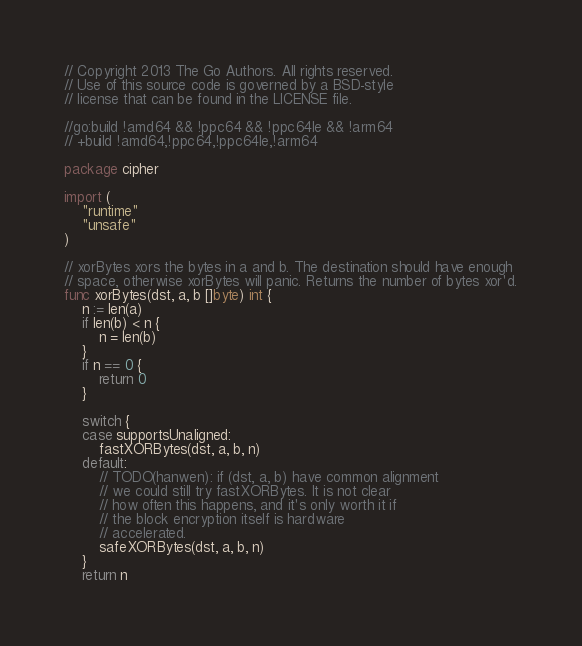Convert code to text. <code><loc_0><loc_0><loc_500><loc_500><_Go_>// Copyright 2013 The Go Authors. All rights reserved.
// Use of this source code is governed by a BSD-style
// license that can be found in the LICENSE file.

//go:build !amd64 && !ppc64 && !ppc64le && !arm64
// +build !amd64,!ppc64,!ppc64le,!arm64

package cipher

import (
	"runtime"
	"unsafe"
)

// xorBytes xors the bytes in a and b. The destination should have enough
// space, otherwise xorBytes will panic. Returns the number of bytes xor'd.
func xorBytes(dst, a, b []byte) int {
	n := len(a)
	if len(b) < n {
		n = len(b)
	}
	if n == 0 {
		return 0
	}

	switch {
	case supportsUnaligned:
		fastXORBytes(dst, a, b, n)
	default:
		// TODO(hanwen): if (dst, a, b) have common alignment
		// we could still try fastXORBytes. It is not clear
		// how often this happens, and it's only worth it if
		// the block encryption itself is hardware
		// accelerated.
		safeXORBytes(dst, a, b, n)
	}
	return n</code> 